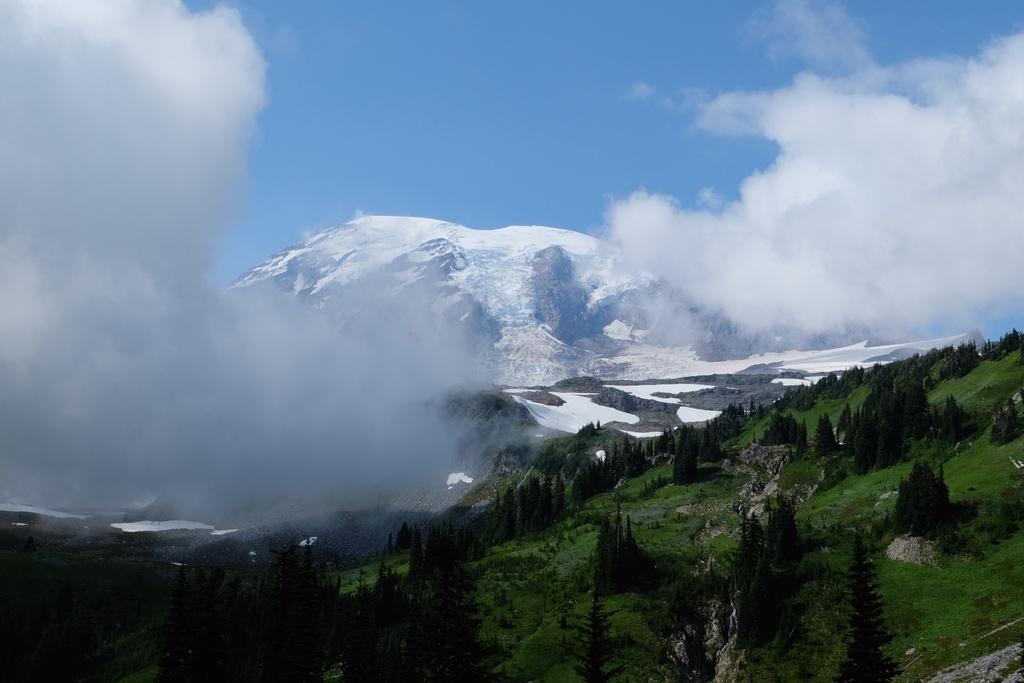Describe this image in one or two sentences. In this image I can see number of trees, mountains, the sky and clouds. 